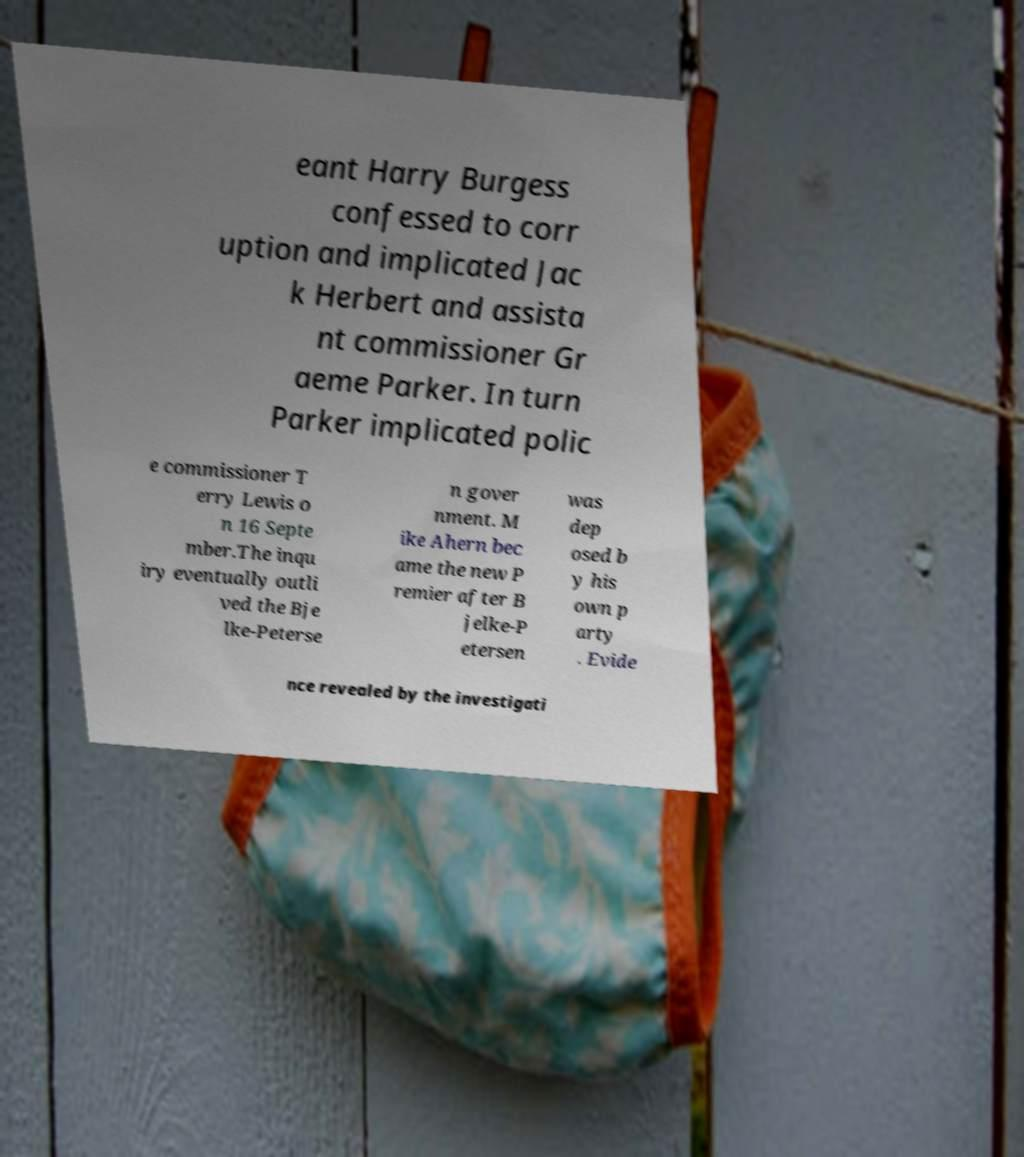Could you extract and type out the text from this image? eant Harry Burgess confessed to corr uption and implicated Jac k Herbert and assista nt commissioner Gr aeme Parker. In turn Parker implicated polic e commissioner T erry Lewis o n 16 Septe mber.The inqu iry eventually outli ved the Bje lke-Peterse n gover nment. M ike Ahern bec ame the new P remier after B jelke-P etersen was dep osed b y his own p arty . Evide nce revealed by the investigati 